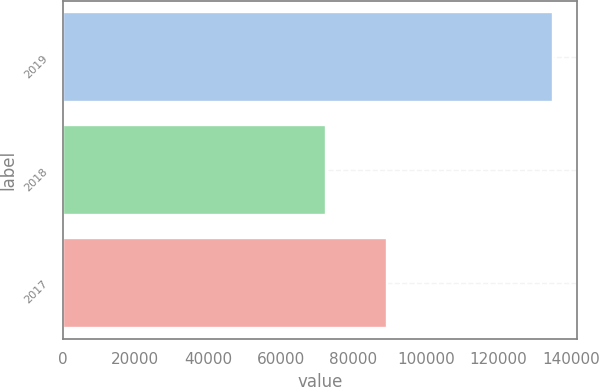<chart> <loc_0><loc_0><loc_500><loc_500><bar_chart><fcel>2019<fcel>2018<fcel>2017<nl><fcel>134952<fcel>72454<fcel>89226<nl></chart> 